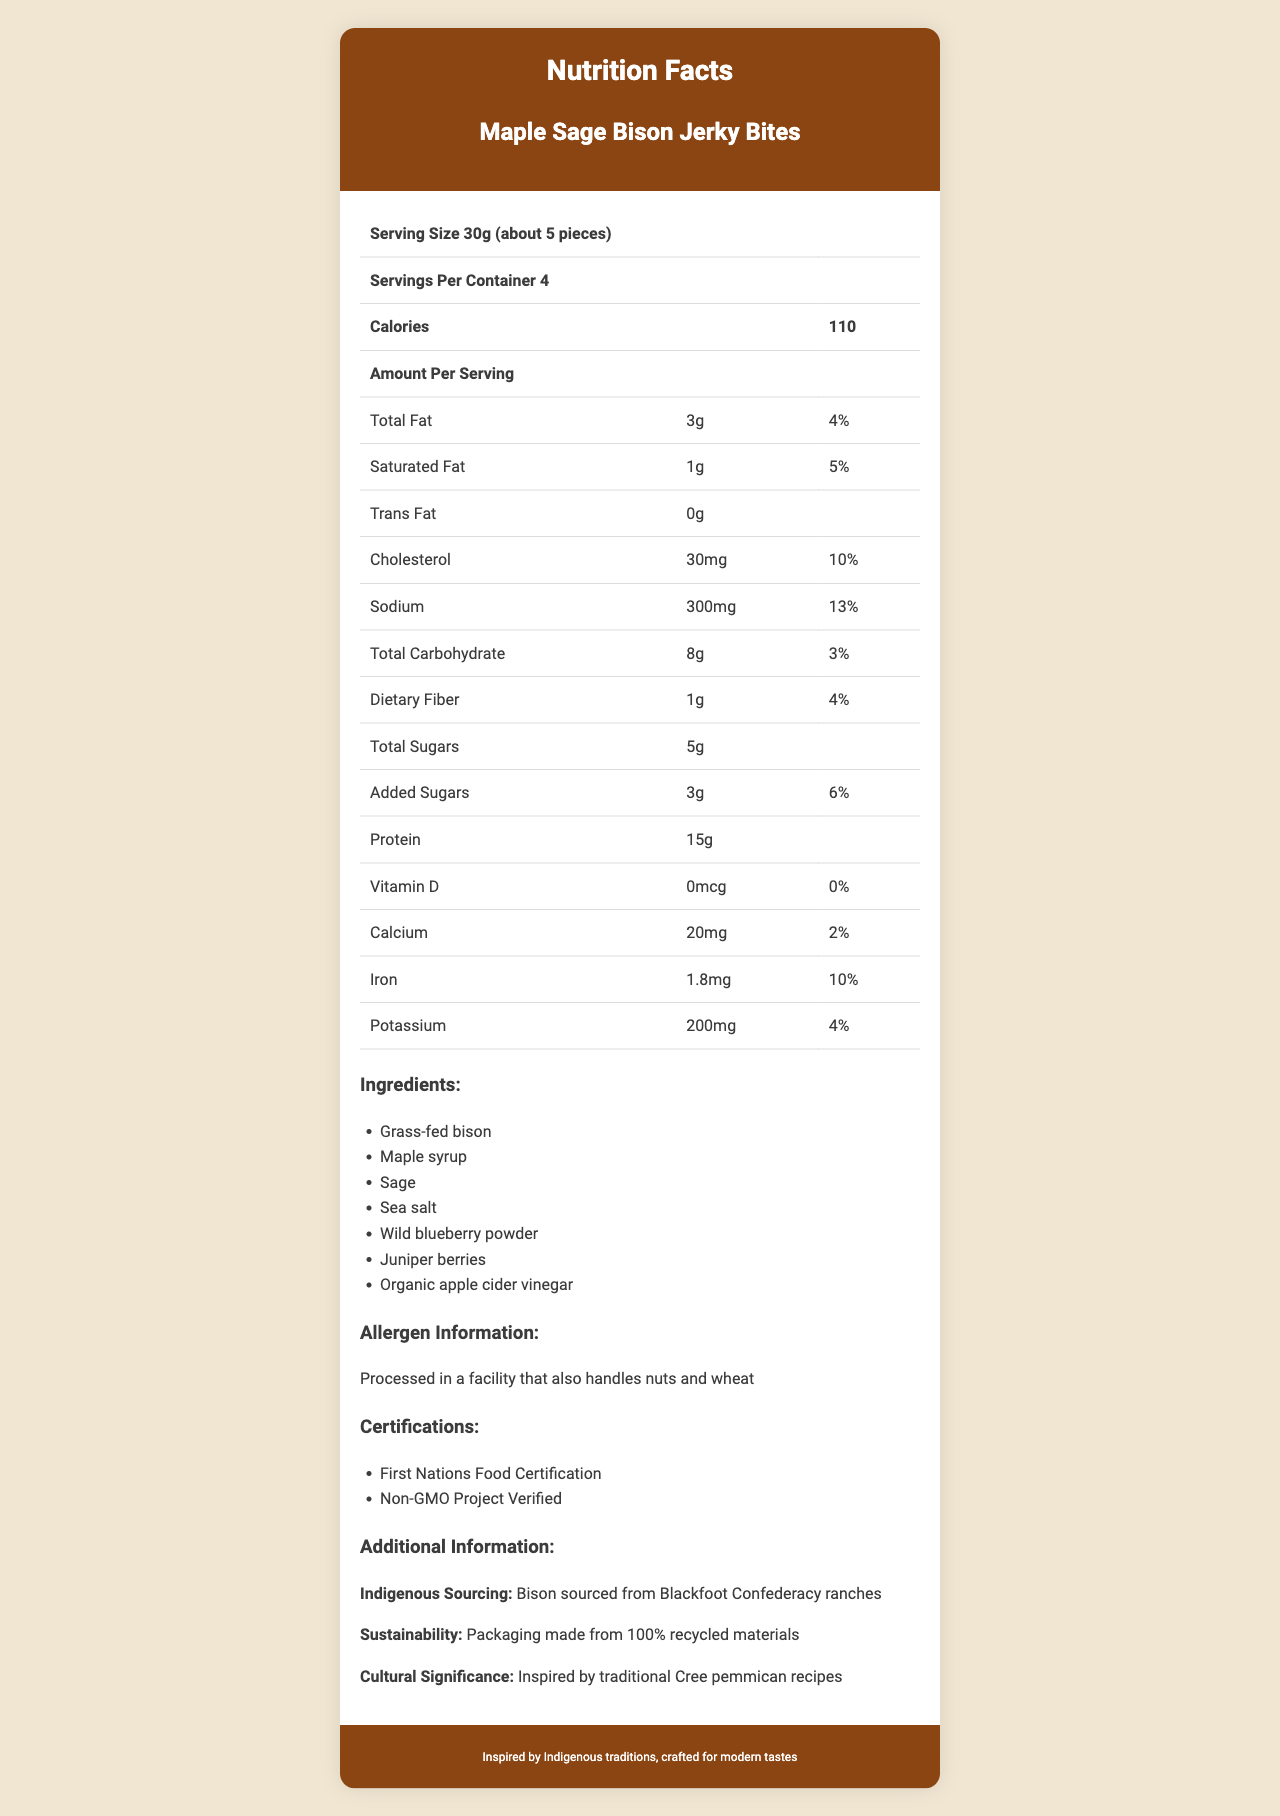what is the serving size of the Maple Sage Bison Jerky Bites? The serving size is clearly listed at the top of the nutrition facts table.
Answer: 30g (about 5 pieces) how many servings are in each container? The number of servings per container is indicated below the serving size.
Answer: 4 how many calories are in one serving of the snack? The calorie count for one serving is prominently displayed in the nutrition facts section.
Answer: 110 what is the total fat content per serving? The total fat content per serving is listed as 3g in the nutrition facts table.
Answer: 3g what percentage of the daily value of cholesterol does one serving provide? The daily value percentage for cholesterol is provided as 10% in the nutrition facts table.
Answer: 10% which traditional ingredient is used in this snack? A. Maple syrup B. Almonds C. Soy sauce Maple syrup is one of the ingredients listed, which is a traditional ingredient.
Answer: A. Maple syrup what is the amount of sodium per serving? The sodium content per serving is indicated as 300mg in the nutrition facts section.
Answer: 300mg what is the protein content per serving? A. 10g B. 12g C. 15g D. 18g The protein content per serving is listed as 15g in the nutrition facts table.
Answer: C. 15g does this product contain any trans fats? The trans fat content is stated as 0g, meaning it does not contain trans fats.
Answer: No what certifications does the product have? The certifications are listed in the document under the certifications section.
Answer: First Nations Food Certification, Non-GMO Project Verified is there any added sugar in the Maple Sage Bison Jerky Bites? The nutrition facts section lists the amount of added sugars as 3g per serving.
Answer: Yes from where is the bison sourced? The additional information section notes that the bison is sourced from Blackfoot Confederacy ranches.
Answer: Blackfoot Confederacy ranches describe the additional information provided about the sustainability and cultural significance of the snack. The additional information section contains these details about sustainability and cultural significance.
Answer: The packaging is made from 100% recycled materials, and the snack is inspired by traditional Cree pemmican recipes. describe the entire document. The document includes comprehensive details about the product, its nutritional content, ingredients, allergen info, certifications, sourcing practices, and cultural inspiration.
Answer: The document is a detailed nutrition facts label for Maple Sage Bison Jerky Bites. It includes information on serving size, calories, fats, cholesterol, sodium, carbohydrates, dietary fiber, sugars, protein, vitamins, minerals, ingredients, allergen information, certifications, indigenous sourcing, sustainability, and cultural significance. how much calcium is there per serving? The calcium content per serving is listed as 20mg in the nutrition facts table.
Answer: 20mg what kind of vinegar is used in the ingredients? The list of ingredients includes organic apple cider vinegar.
Answer: Organic apple cider vinegar can this product be consumed by people with nut allergies? The allergen information states it is processed in a facility that also handles nuts, but it does not confirm whether the product itself contains nuts.
Answer: Cannot be determined what is the inspiration for this snack? The additional information section states the cultural significance of the snack as being inspired by traditional Cree pemmican recipes.
Answer: Traditional Cree pemmican recipes 